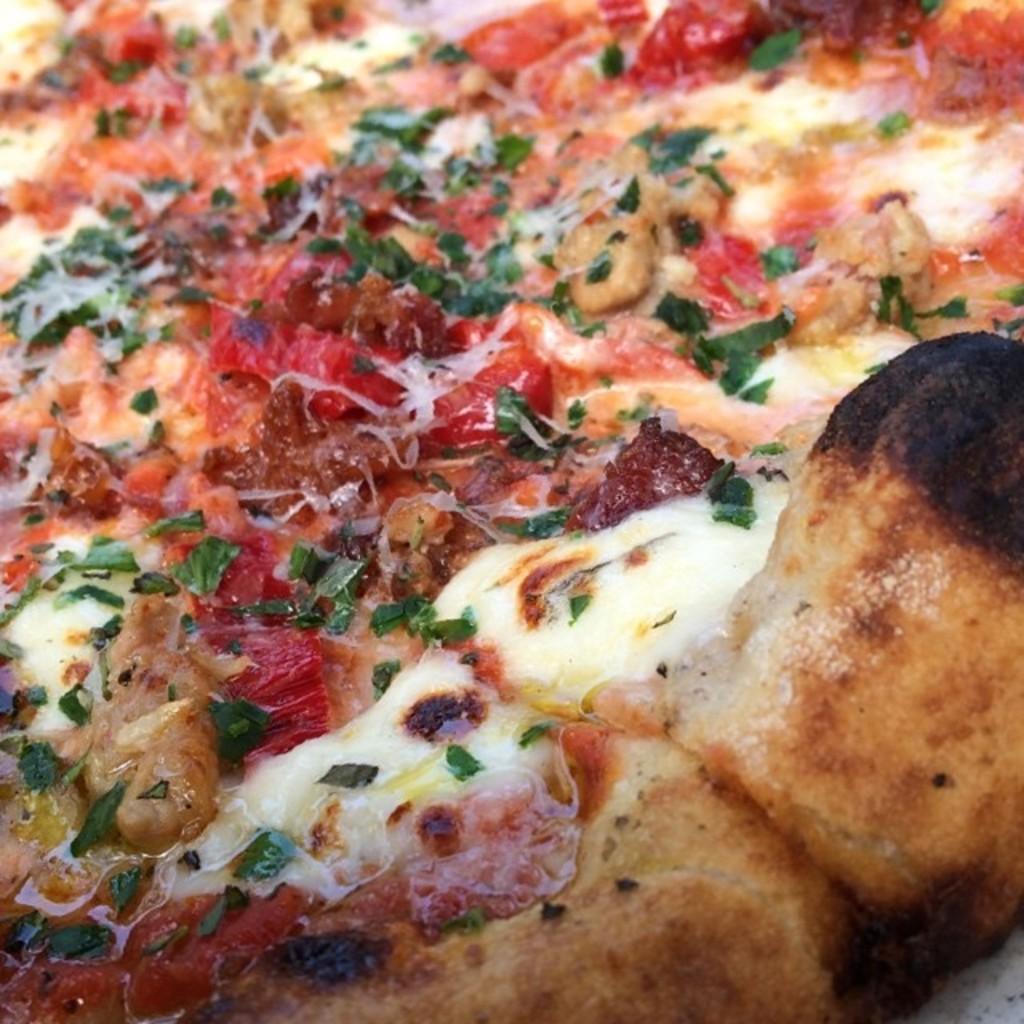In one or two sentences, can you explain what this image depicts? In the image there is a pizza, it has cheese, sauce and some other items sprinkled over it. 